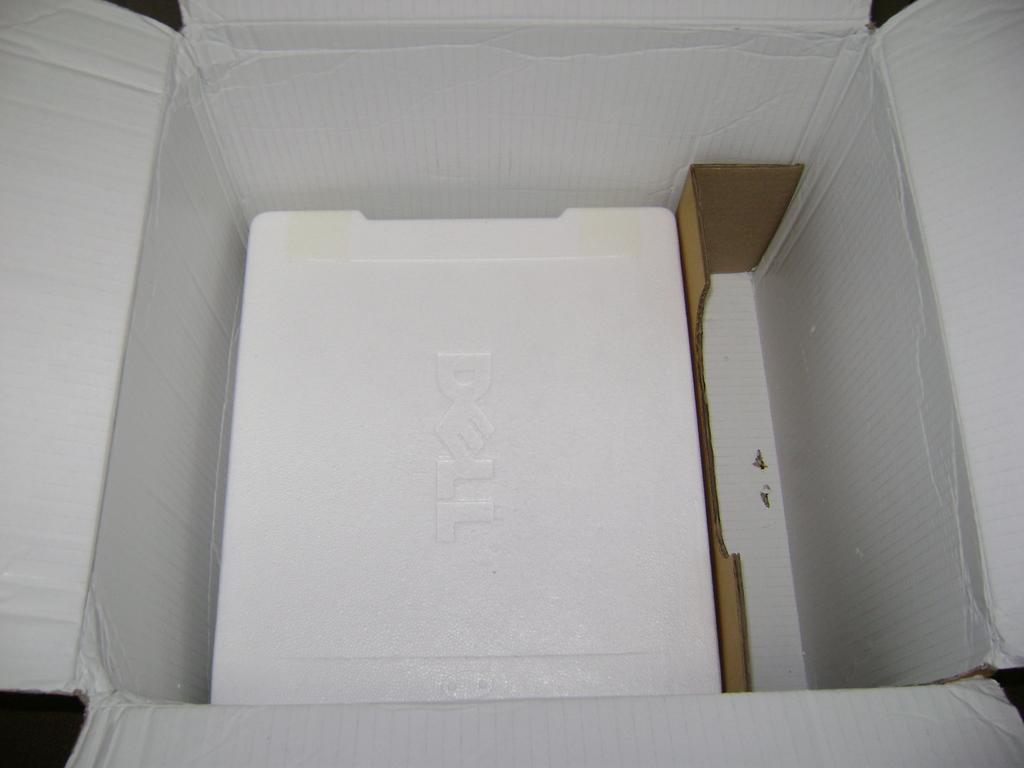<image>
Give a short and clear explanation of the subsequent image. A cardboard box has Dell branded polystyrene inside. 